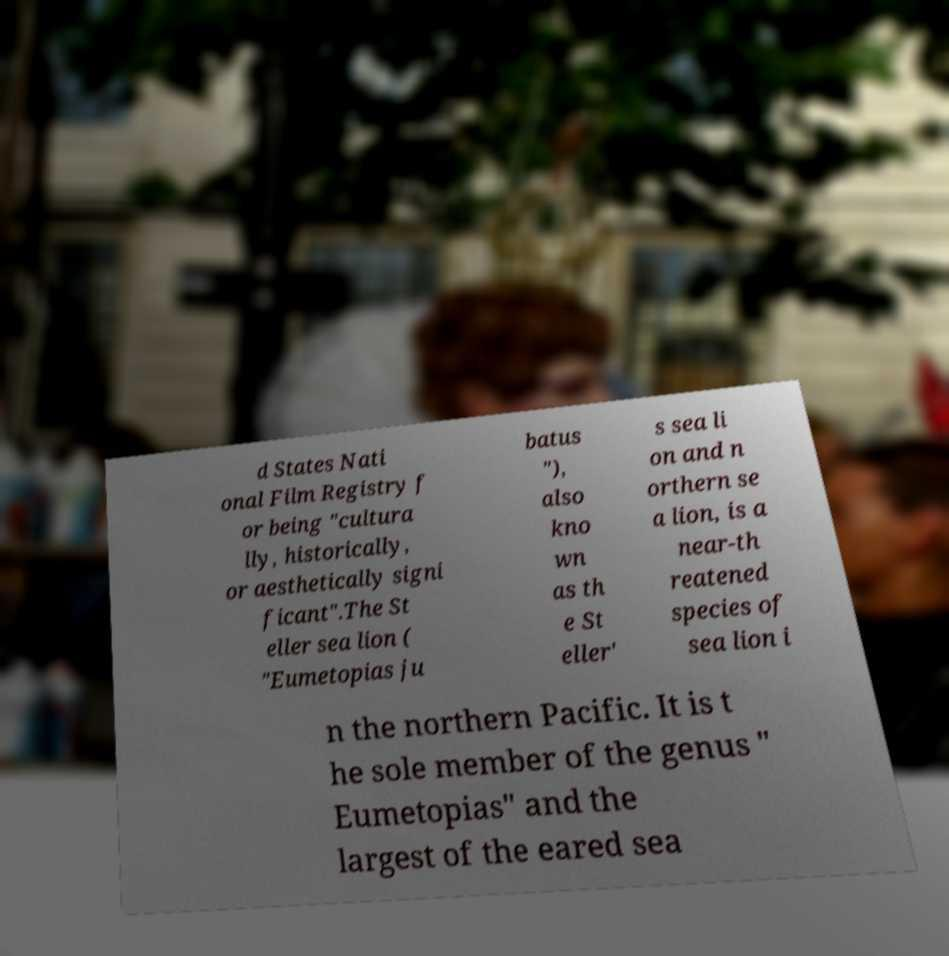For documentation purposes, I need the text within this image transcribed. Could you provide that? d States Nati onal Film Registry f or being "cultura lly, historically, or aesthetically signi ficant".The St eller sea lion ( "Eumetopias ju batus "), also kno wn as th e St eller' s sea li on and n orthern se a lion, is a near-th reatened species of sea lion i n the northern Pacific. It is t he sole member of the genus " Eumetopias" and the largest of the eared sea 